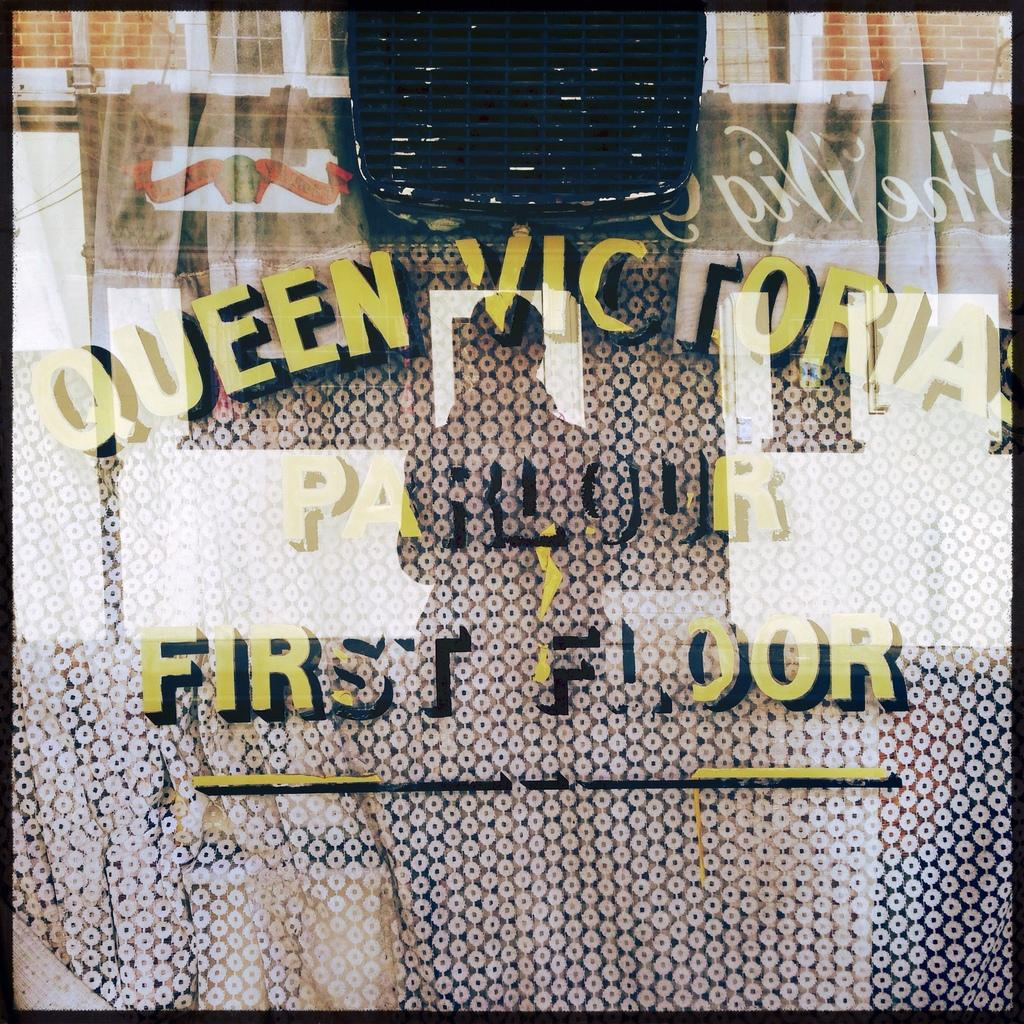<image>
Write a terse but informative summary of the picture. A window with Queen Victoria Parlour First Floor printed on it. 